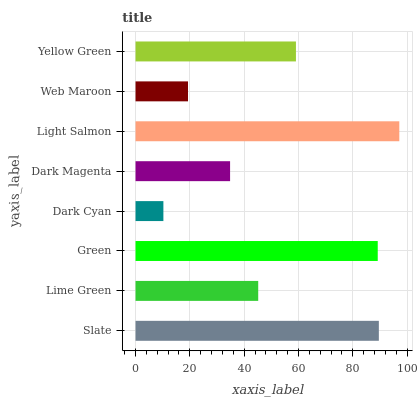Is Dark Cyan the minimum?
Answer yes or no. Yes. Is Light Salmon the maximum?
Answer yes or no. Yes. Is Lime Green the minimum?
Answer yes or no. No. Is Lime Green the maximum?
Answer yes or no. No. Is Slate greater than Lime Green?
Answer yes or no. Yes. Is Lime Green less than Slate?
Answer yes or no. Yes. Is Lime Green greater than Slate?
Answer yes or no. No. Is Slate less than Lime Green?
Answer yes or no. No. Is Yellow Green the high median?
Answer yes or no. Yes. Is Lime Green the low median?
Answer yes or no. Yes. Is Dark Cyan the high median?
Answer yes or no. No. Is Dark Magenta the low median?
Answer yes or no. No. 